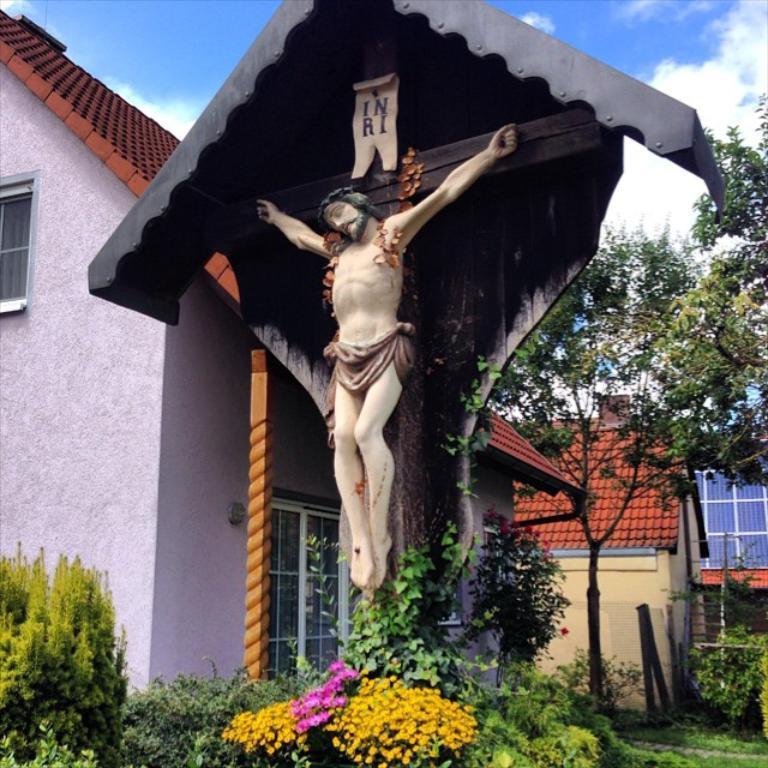Could you give a brief overview of what you see in this image? In this image in the front there are plants and flowers. In the center there is a statue on the wooden stand with some text written on it and in the background there are houses and trees and the sky is cloudy and there is grass on the ground and there is a fence and there are stones. 